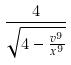<formula> <loc_0><loc_0><loc_500><loc_500>\frac { 4 } { \sqrt { 4 - \frac { v ^ { 9 } } { x ^ { 9 } } } }</formula> 